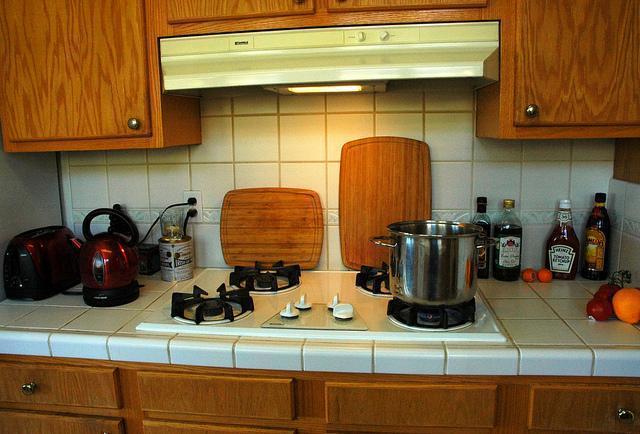What is a favorite condiment of the owner?
Select the accurate answer and provide justification: `Answer: choice
Rationale: srationale.`
Options: Soy sauce, mustard, relish, ketchup. Answer: ketchup.
Rationale: The answer is not knowable, but answer a is present in the image while the other answers are not which could indicate the owner's preference. 